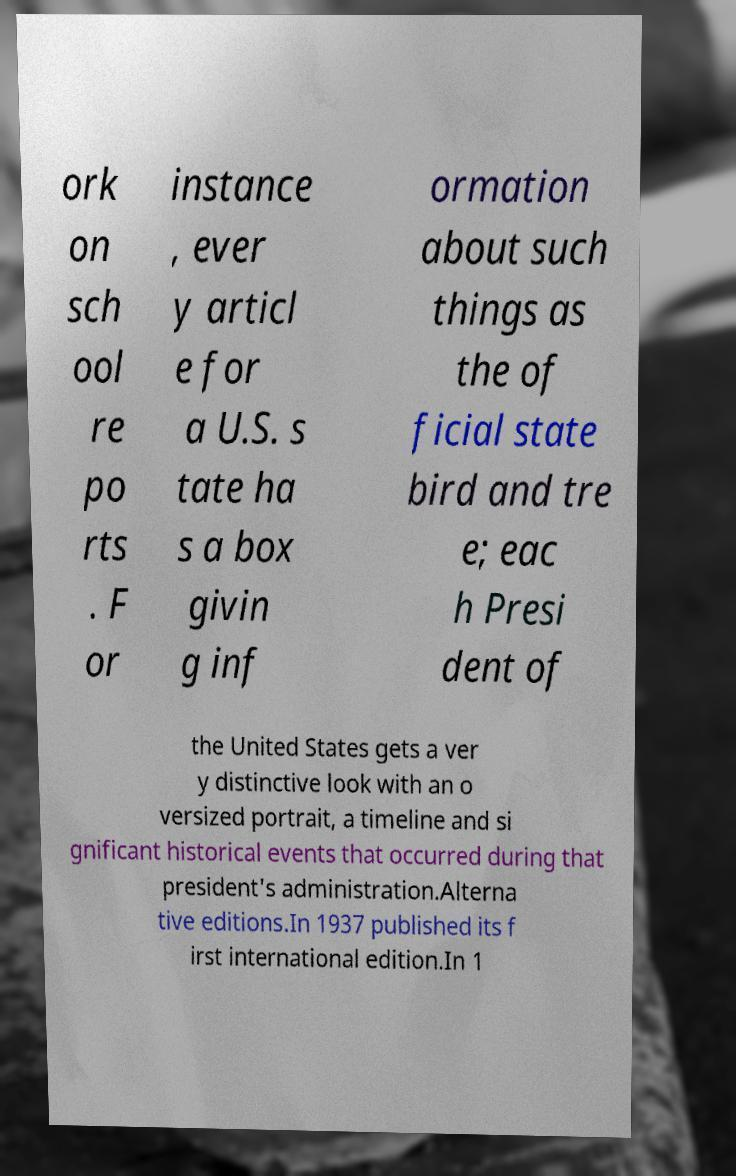I need the written content from this picture converted into text. Can you do that? ork on sch ool re po rts . F or instance , ever y articl e for a U.S. s tate ha s a box givin g inf ormation about such things as the of ficial state bird and tre e; eac h Presi dent of the United States gets a ver y distinctive look with an o versized portrait, a timeline and si gnificant historical events that occurred during that president's administration.Alterna tive editions.In 1937 published its f irst international edition.In 1 